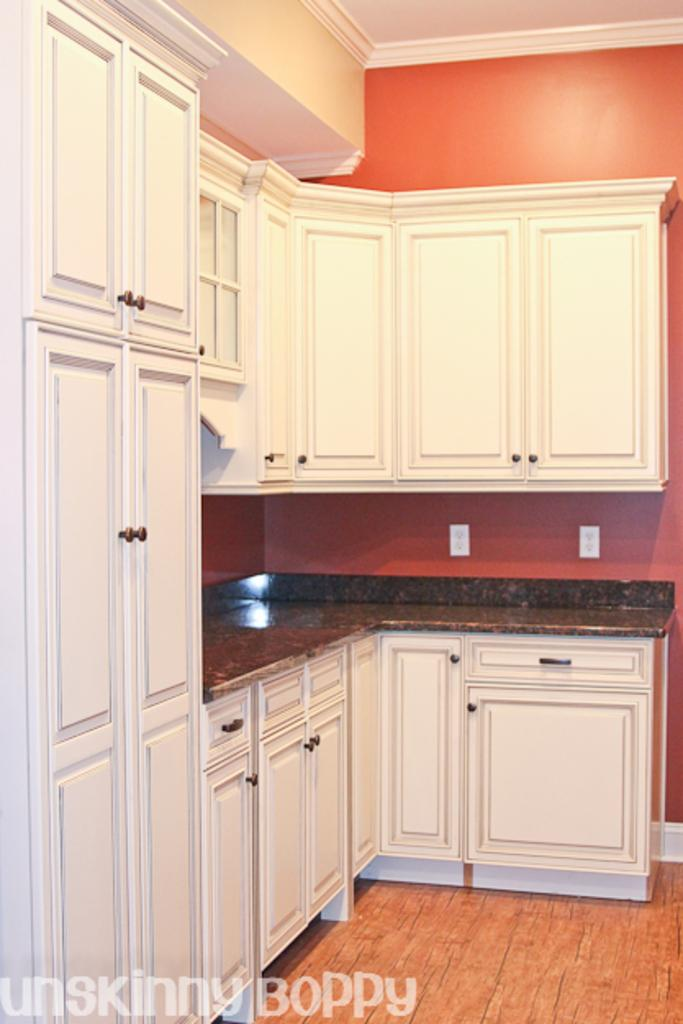What type of furniture is attached to the wall in the image? There are cupboards on the wall in the image. What other objects can be seen on the wall in the image? There are white color objects that look like plug boards on the wall in the image. What type of linen is being used for the activity in the image? There is no linen or activity present in the image; it only features cupboards and white objects that look like plug boards on the wall. What color is the paint used on the wall in the image? The provided facts do not mention the color of the paint used on the wall in the image. 